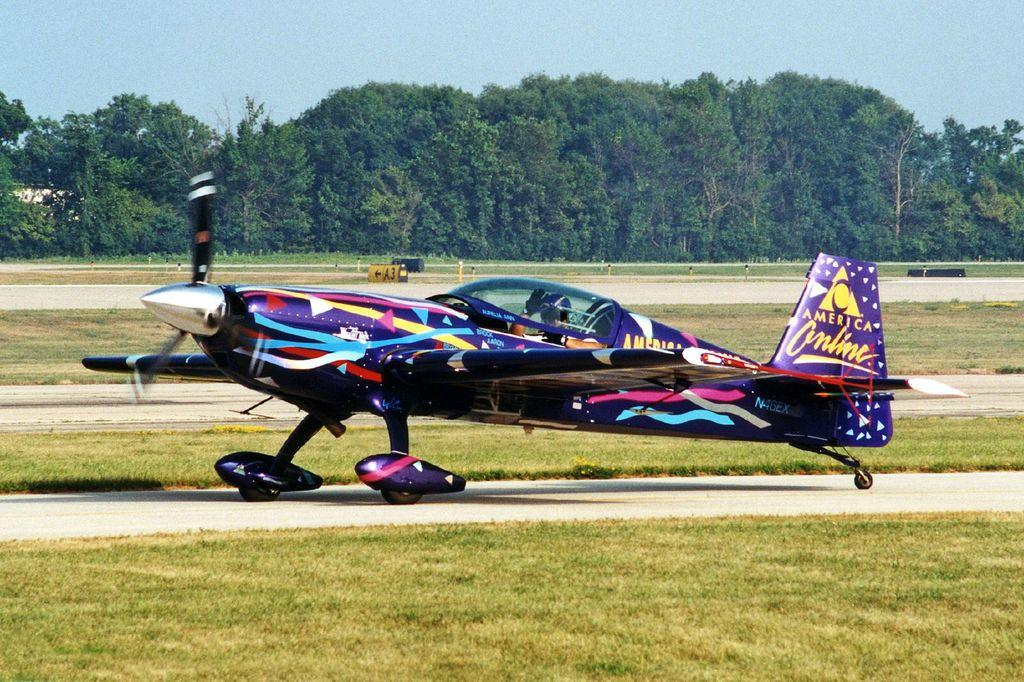<image>
Give a short and clear explanation of the subsequent image. A small propellor plane is sponsored by America Online. 